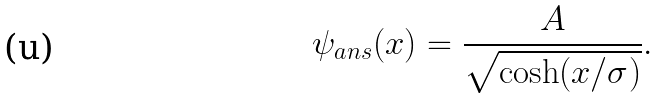Convert formula to latex. <formula><loc_0><loc_0><loc_500><loc_500>\psi _ { a n s } ( x ) = \frac { A } { \sqrt { \cosh ( x / \sigma ) } } .</formula> 